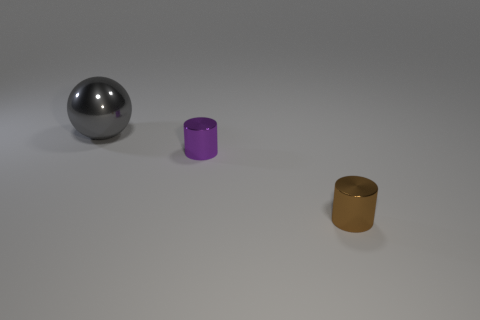Add 1 tiny metallic things. How many objects exist? 4 Subtract all balls. How many objects are left? 2 Add 2 purple shiny things. How many purple shiny things are left? 3 Add 1 brown cylinders. How many brown cylinders exist? 2 Subtract 1 gray balls. How many objects are left? 2 Subtract all large gray metal objects. Subtract all tiny things. How many objects are left? 0 